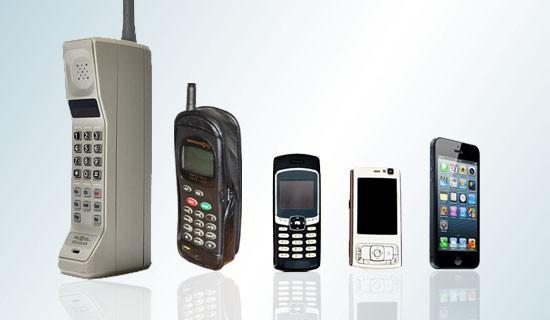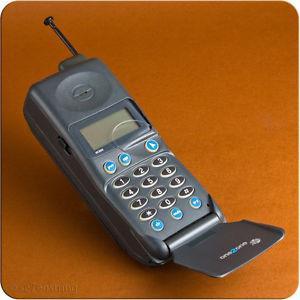The first image is the image on the left, the second image is the image on the right. Evaluate the accuracy of this statement regarding the images: "There are three black phones in a row with small antennas on the right side.". Is it true? Answer yes or no. No. The first image is the image on the left, the second image is the image on the right. For the images shown, is this caption "In each image, three or more cellphones with keypads and antenna knobs are shown upright and side by side." true? Answer yes or no. No. 